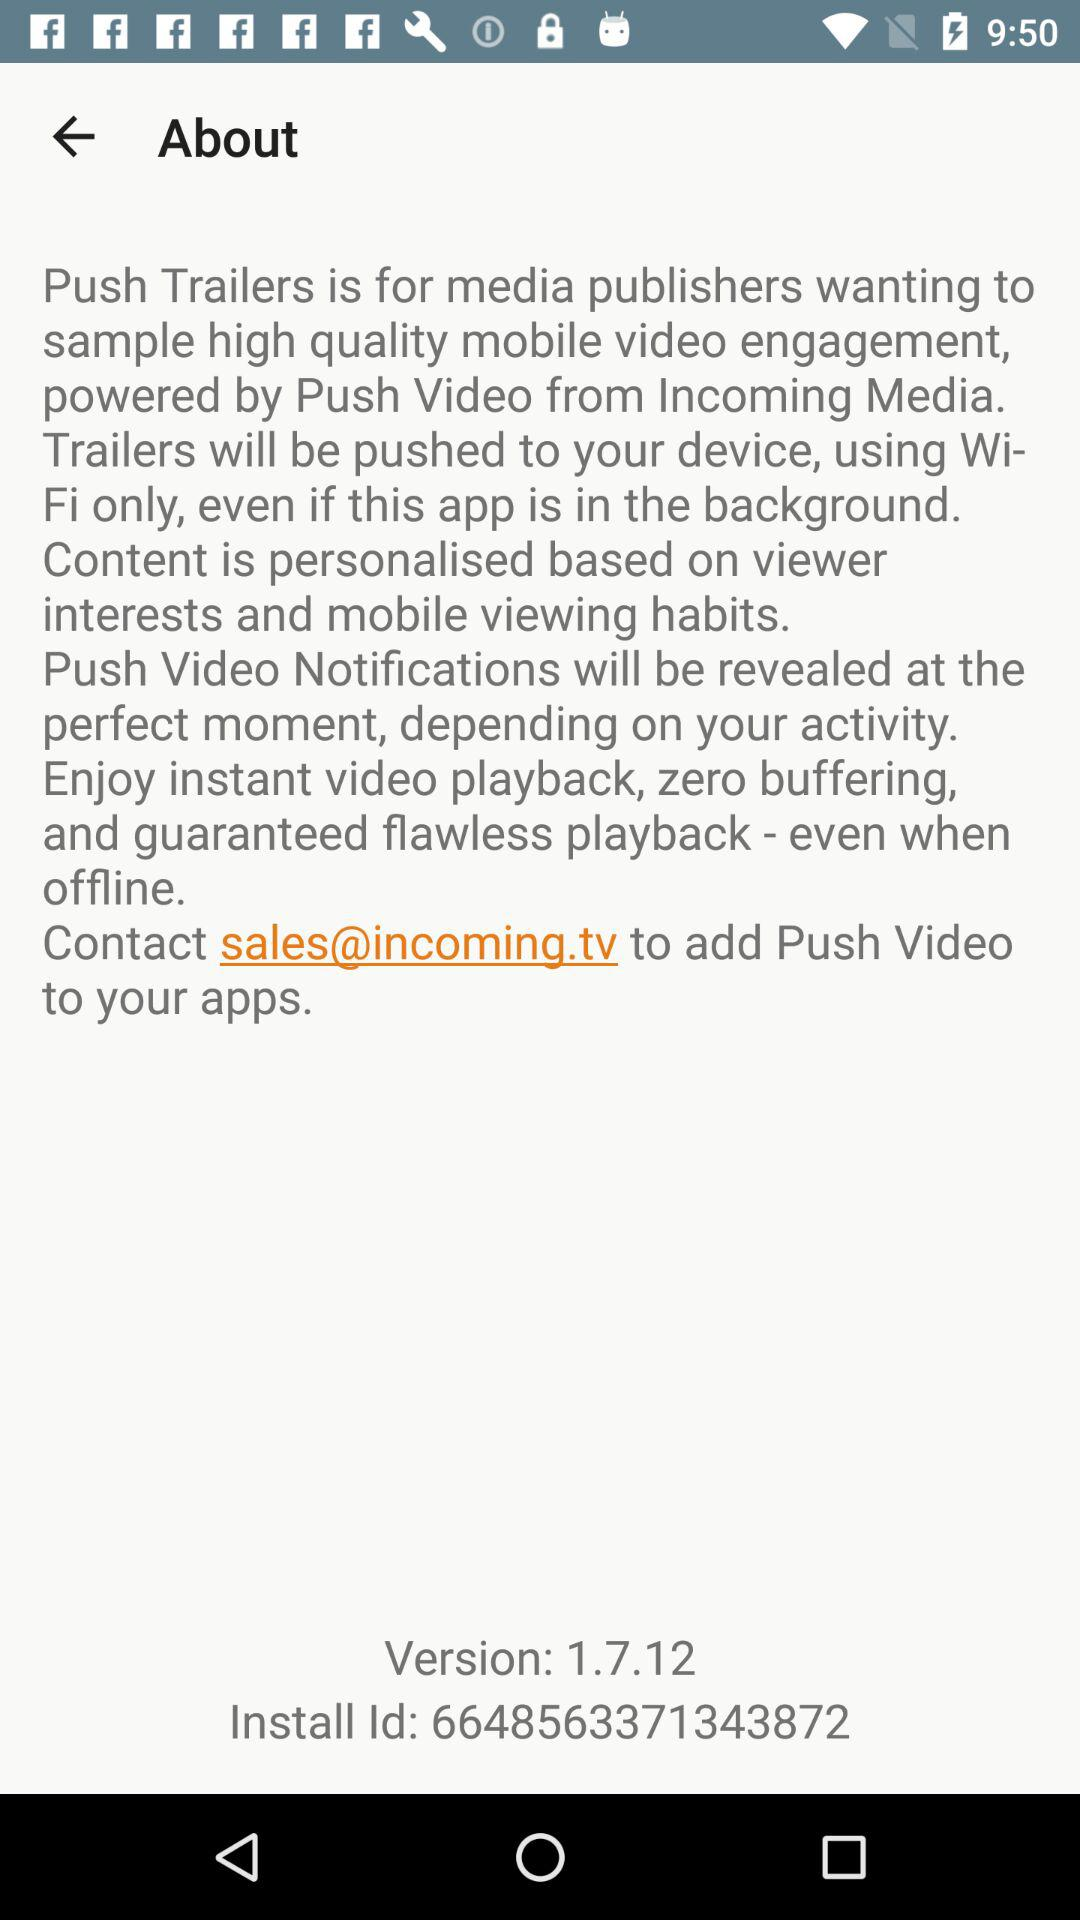What is the email address to contact "to add a push video to your app"? The email address is "sales@incoming.tv". 